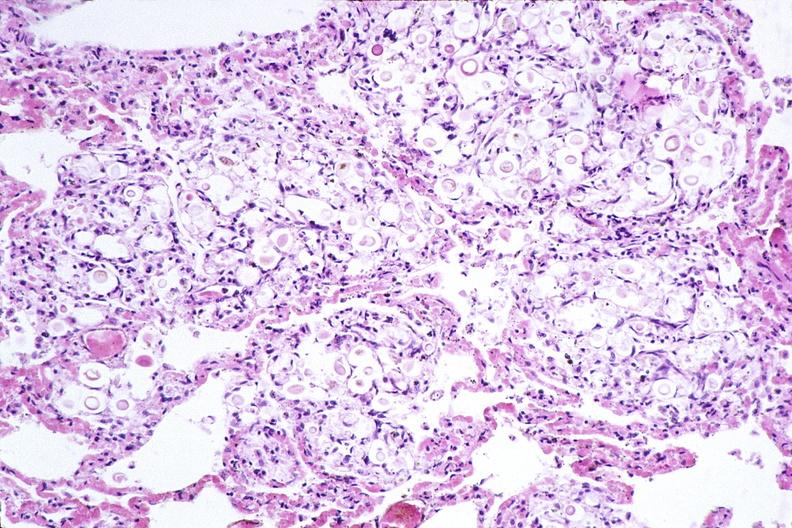s respiratory present?
Answer the question using a single word or phrase. Yes 